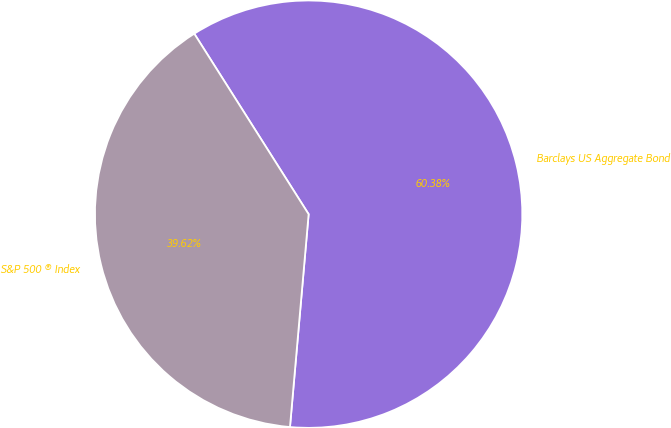Convert chart to OTSL. <chart><loc_0><loc_0><loc_500><loc_500><pie_chart><fcel>Barclays US Aggregate Bond<fcel>S&P 500 ® Index<nl><fcel>60.38%<fcel>39.62%<nl></chart> 